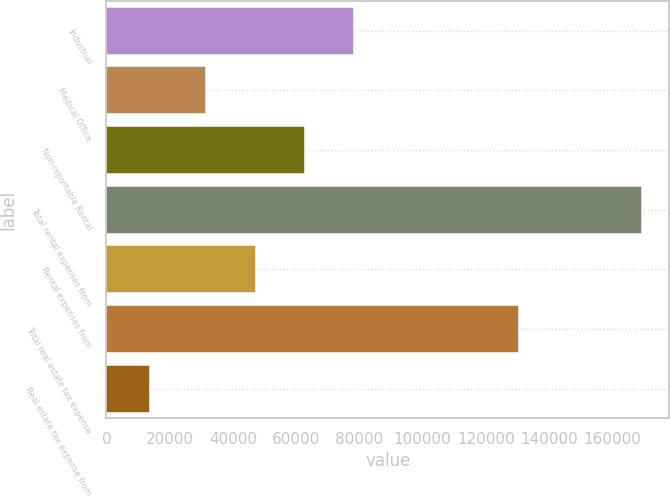Convert chart to OTSL. <chart><loc_0><loc_0><loc_500><loc_500><bar_chart><fcel>Industrial<fcel>Medical Office<fcel>Non-reportable Rental<fcel>Total rental expenses from<fcel>Rental expenses from<fcel>Total real estate tax expense<fcel>Real estate tax expense from<nl><fcel>78349.1<fcel>31649<fcel>62782.4<fcel>169534<fcel>47215.7<fcel>130580<fcel>13867<nl></chart> 